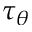<formula> <loc_0><loc_0><loc_500><loc_500>\tau _ { \theta }</formula> 